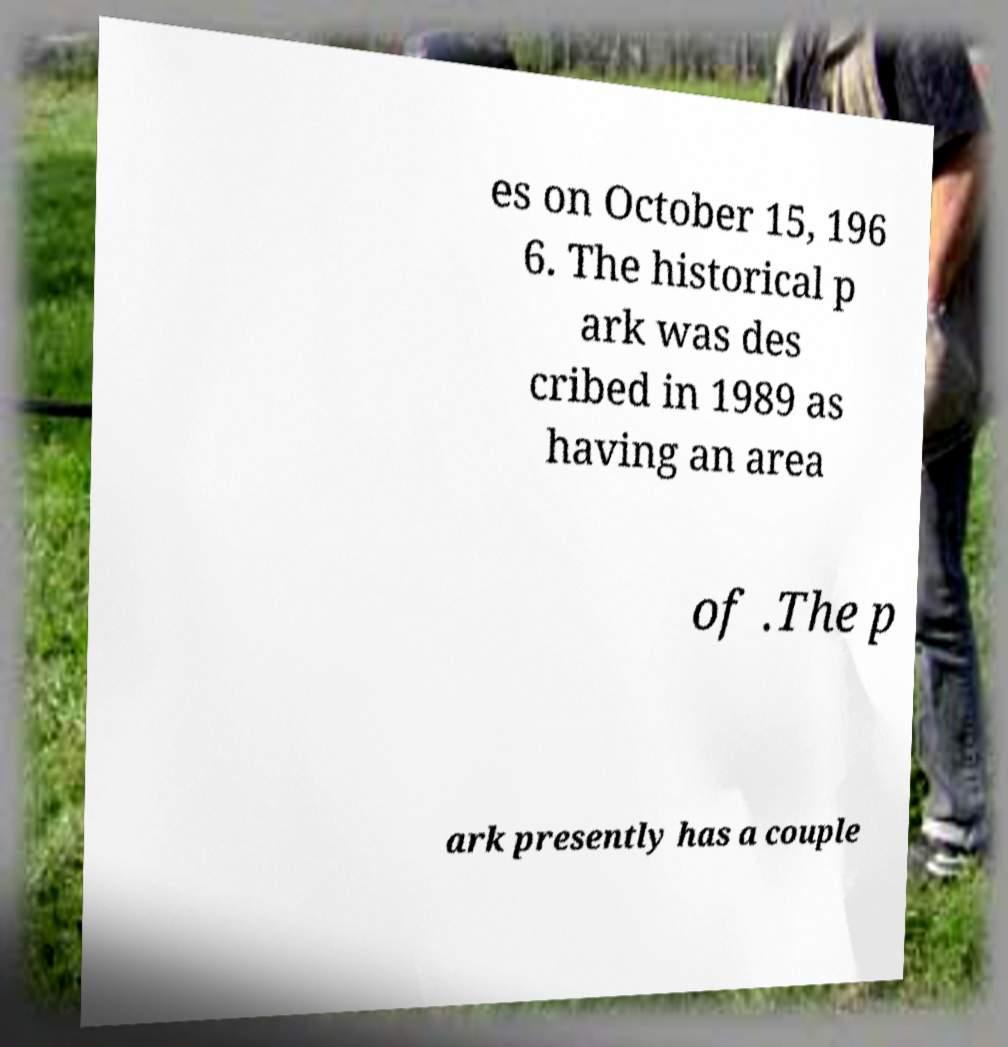Could you assist in decoding the text presented in this image and type it out clearly? es on October 15, 196 6. The historical p ark was des cribed in 1989 as having an area of .The p ark presently has a couple 